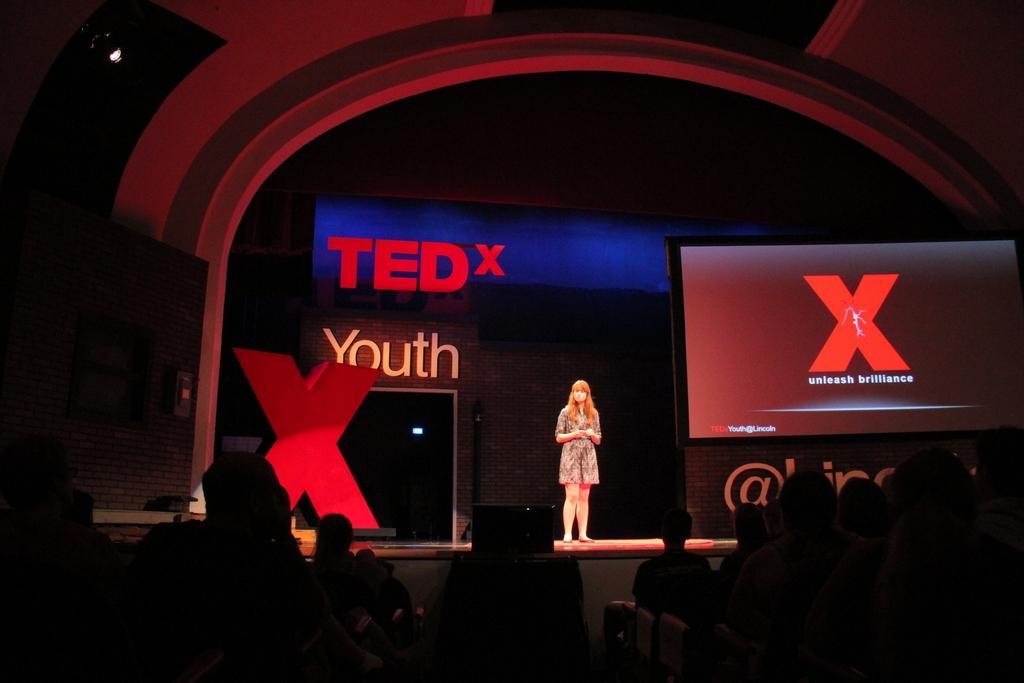Can you describe this image briefly? In this image we can see a woman standing on the floor. In the background we can see a screen, hoarding, and wall. At the bottom of the image we can see few people. 